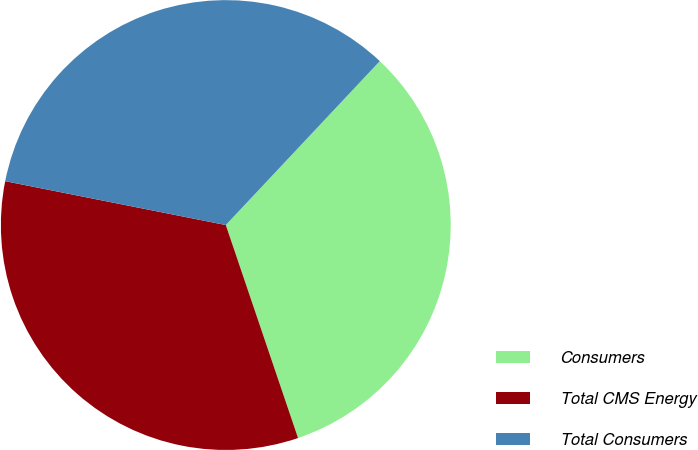<chart> <loc_0><loc_0><loc_500><loc_500><pie_chart><fcel>Consumers<fcel>Total CMS Energy<fcel>Total Consumers<nl><fcel>32.79%<fcel>33.33%<fcel>33.88%<nl></chart> 